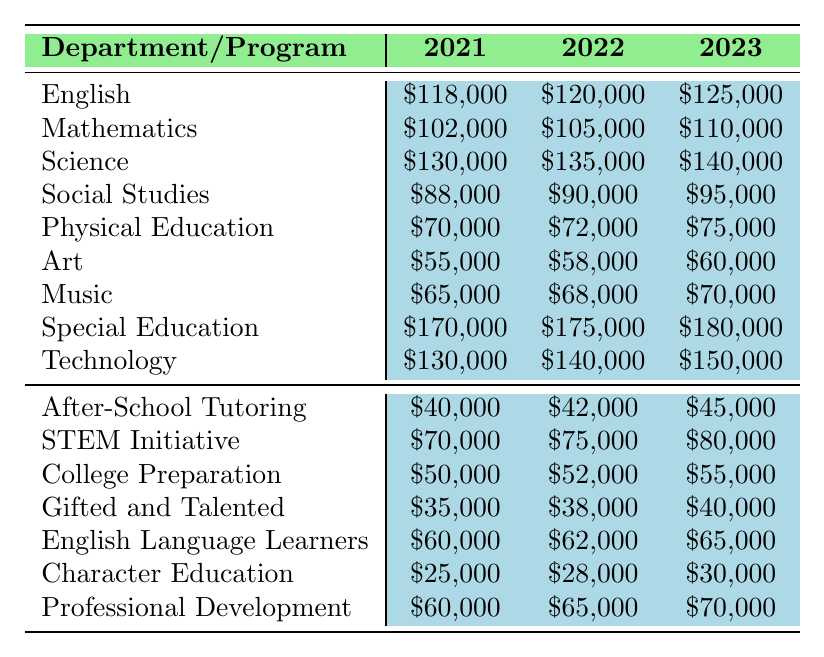What was the budget allocation for the Science department in 2022? Looking at the table, we find the value under the Science row for the year 2022, which shows \$135,000.
Answer: \$135,000 Which department received the highest budget allocation in 2023? The highest budget allocation is found in the Special Education row for the year 2023, which is \$180,000.
Answer: Special Education What was the percentage increase in the budget for Mathematics from 2021 to 2023? We calculate the increase as follows: \$110,000 (2023) - \$102,000 (2021) = \$8,000. Then, the percentage increase is (\$8,000 / \$102,000) * 100 ≈ 7.84%.
Answer: Approximately 7.84% Is the budget for After-School Tutoring higher in 2023 compared to 2021? To answer this, we compare the two values: \$45,000 (2023) vs. \$40,000 (2021). Since \$45,000 is greater, the statement is true.
Answer: Yes What is the total budget allocated to the Art and Music departments in 2022? We add the values for Art and Music for 2022: \$58,000 (Art) + \$68,000 (Music) = \$126,000.
Answer: \$126,000 Which program saw the smallest budget increase from 2021 to 2023 and what was the amount? We compare the increases for all programs: After-School Tutoring increased by \$5,000, Gifted and Talented by \$5,000, and Character Education by \$5,000 as well. Among these, all have the same increase.
Answer: \$5,000 for After-School Tutoring, Gifted and Talented, and Character Education What is the average budget allocation for Technology over the three years? We first sum up the allocations: \$130,000 (2021) + \$140,000 (2022) + \$150,000 (2023) = \$420,000. We then divide by 3 to get the average: \$420,000 / 3 = \$140,000.
Answer: \$140,000 Did the budget for Social Studies increase by more than 10% from 2021 to 2023? We calculate the increase: \$95,000 (2023) - \$88,000 (2021) = \$7,000. The percentage increase is (\$7,000 / \$88,000) * 100 ≈ 7.95%, which is less than 10%.
Answer: No What are the total allocated funds for all departments in 2023? We add up all department allocations for 2023: \$125,000 + \$110,000 + \$140,000 + \$95,000 + \$75,000 + \$60,000 + \$70,000 + \$180,000 + \$150,000 = \$1,005,000.
Answer: \$1,005,000 Which department had the least budget allocation in 2022 and what was the amount? Looking through the 2022 allocations, Art had the least with \$58,000.
Answer: Art, \$58,000 